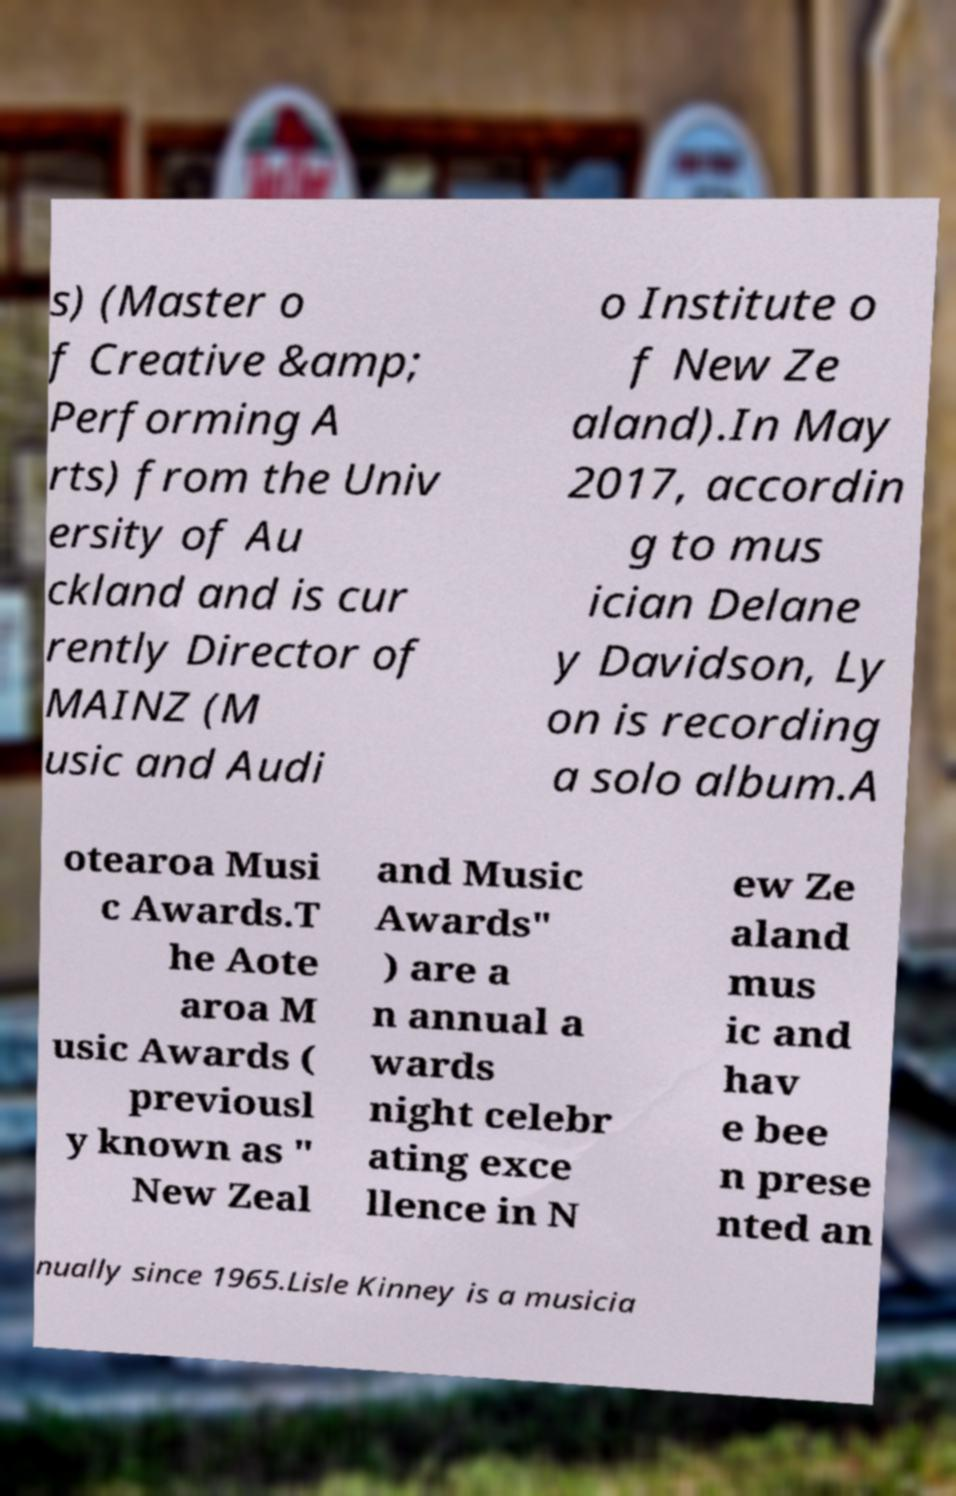I need the written content from this picture converted into text. Can you do that? s) (Master o f Creative &amp; Performing A rts) from the Univ ersity of Au ckland and is cur rently Director of MAINZ (M usic and Audi o Institute o f New Ze aland).In May 2017, accordin g to mus ician Delane y Davidson, Ly on is recording a solo album.A otearoa Musi c Awards.T he Aote aroa M usic Awards ( previousl y known as " New Zeal and Music Awards" ) are a n annual a wards night celebr ating exce llence in N ew Ze aland mus ic and hav e bee n prese nted an nually since 1965.Lisle Kinney is a musicia 